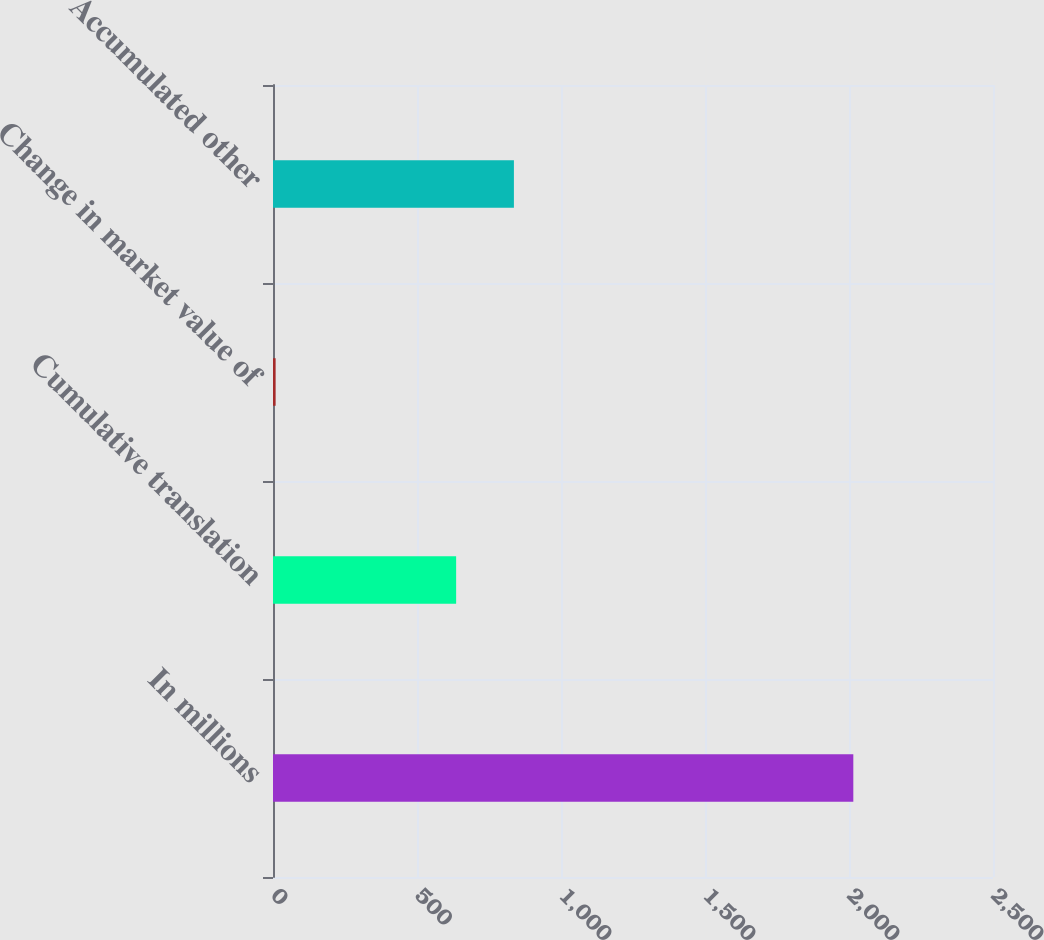Convert chart to OTSL. <chart><loc_0><loc_0><loc_500><loc_500><bar_chart><fcel>In millions<fcel>Cumulative translation<fcel>Change in market value of<fcel>Accumulated other<nl><fcel>2015<fcel>635.9<fcel>9.1<fcel>836.49<nl></chart> 